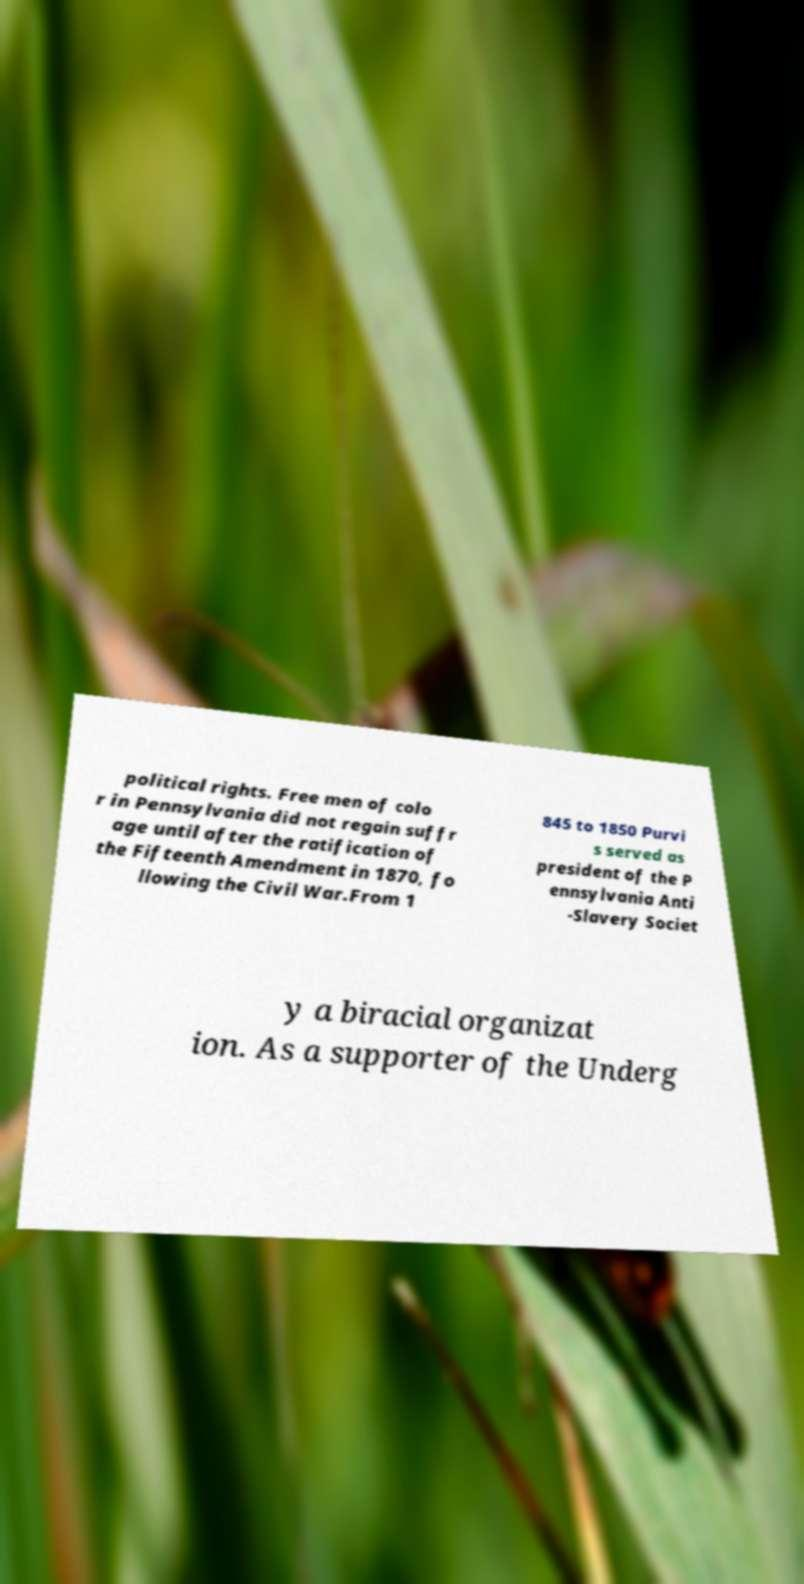What messages or text are displayed in this image? I need them in a readable, typed format. political rights. Free men of colo r in Pennsylvania did not regain suffr age until after the ratification of the Fifteenth Amendment in 1870, fo llowing the Civil War.From 1 845 to 1850 Purvi s served as president of the P ennsylvania Anti -Slavery Societ y a biracial organizat ion. As a supporter of the Underg 